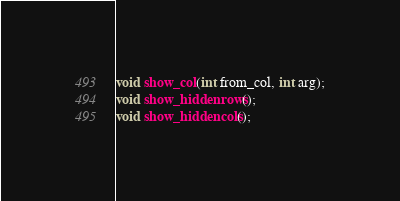Convert code to text. <code><loc_0><loc_0><loc_500><loc_500><_C_>void show_col(int from_col, int arg);
void show_hiddenrows();
void show_hiddencols();
</code> 